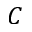Convert formula to latex. <formula><loc_0><loc_0><loc_500><loc_500>C</formula> 